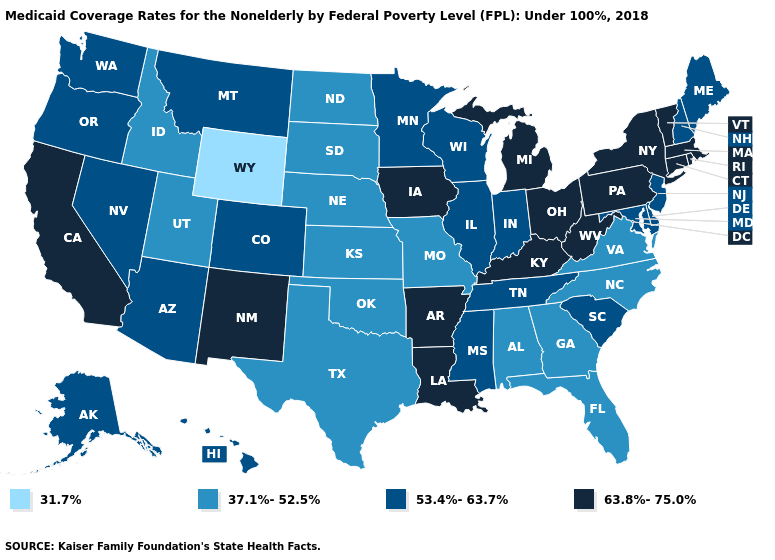What is the value of Montana?
Quick response, please. 53.4%-63.7%. Which states have the highest value in the USA?
Short answer required. Arkansas, California, Connecticut, Iowa, Kentucky, Louisiana, Massachusetts, Michigan, New Mexico, New York, Ohio, Pennsylvania, Rhode Island, Vermont, West Virginia. What is the value of Pennsylvania?
Answer briefly. 63.8%-75.0%. Which states have the lowest value in the Northeast?
Be succinct. Maine, New Hampshire, New Jersey. Which states have the lowest value in the USA?
Short answer required. Wyoming. Does Missouri have the highest value in the MidWest?
Write a very short answer. No. Among the states that border Missouri , does Kentucky have the lowest value?
Keep it brief. No. Among the states that border North Dakota , which have the highest value?
Be succinct. Minnesota, Montana. Name the states that have a value in the range 37.1%-52.5%?
Be succinct. Alabama, Florida, Georgia, Idaho, Kansas, Missouri, Nebraska, North Carolina, North Dakota, Oklahoma, South Dakota, Texas, Utah, Virginia. Name the states that have a value in the range 63.8%-75.0%?
Answer briefly. Arkansas, California, Connecticut, Iowa, Kentucky, Louisiana, Massachusetts, Michigan, New Mexico, New York, Ohio, Pennsylvania, Rhode Island, Vermont, West Virginia. What is the value of Alabama?
Write a very short answer. 37.1%-52.5%. Name the states that have a value in the range 37.1%-52.5%?
Answer briefly. Alabama, Florida, Georgia, Idaho, Kansas, Missouri, Nebraska, North Carolina, North Dakota, Oklahoma, South Dakota, Texas, Utah, Virginia. Does Oklahoma have the highest value in the USA?
Give a very brief answer. No. Does West Virginia have the lowest value in the South?
Short answer required. No. Does Maryland have the highest value in the South?
Answer briefly. No. 